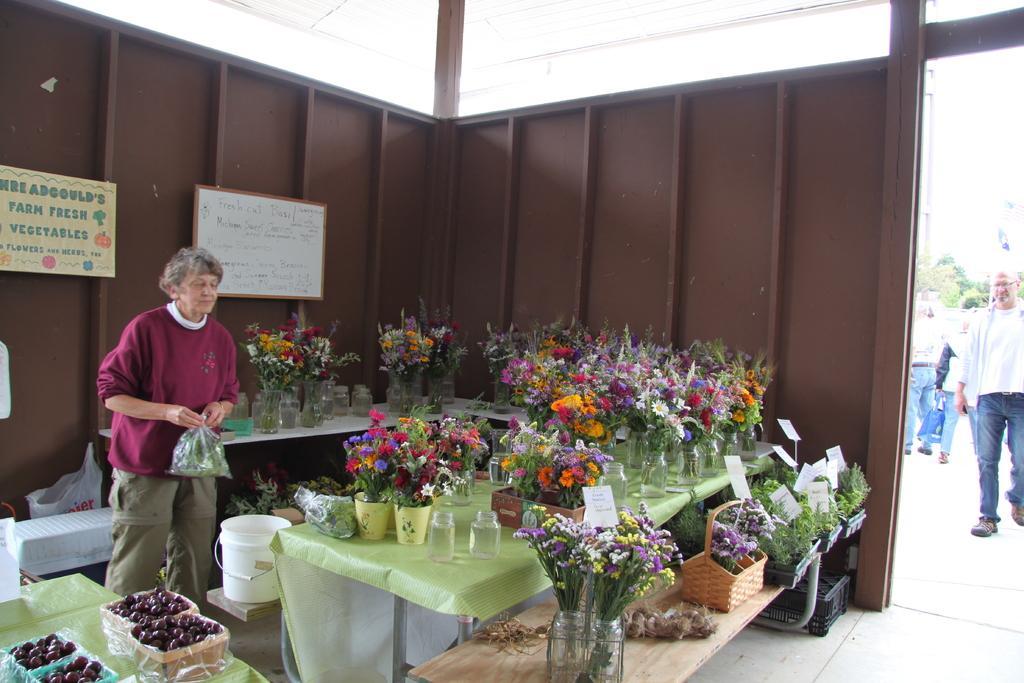Describe this image in one or two sentences. In this picture there is a woman standing and holding a cover. There are many flower pots on the table. There is a bottle, bucket and other objects on the table. There is a white board and poster. There are few people at the background. 